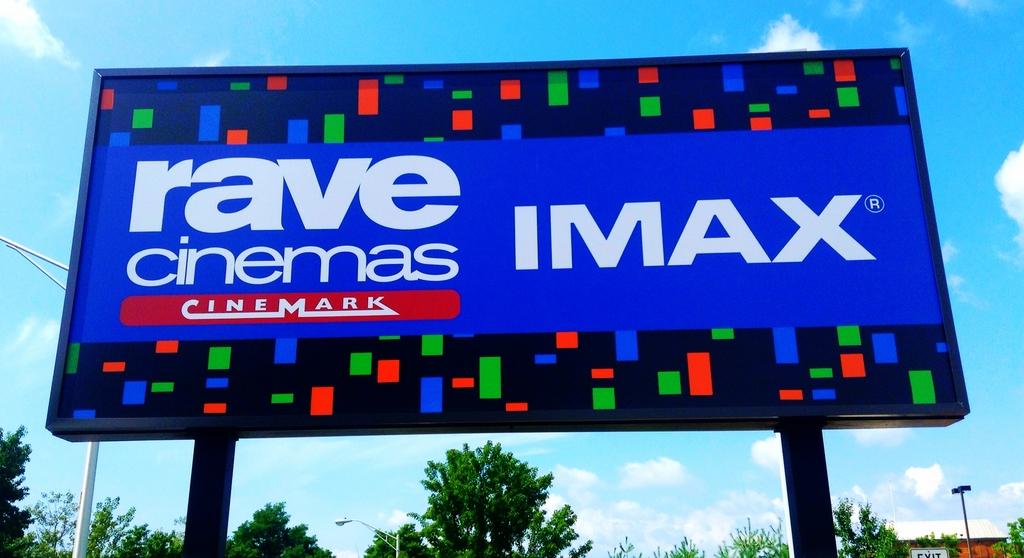What is the name of the movie theater?
Your response must be concise. Rave cinemas. What company owns the theater?
Keep it short and to the point. Cinemark. 